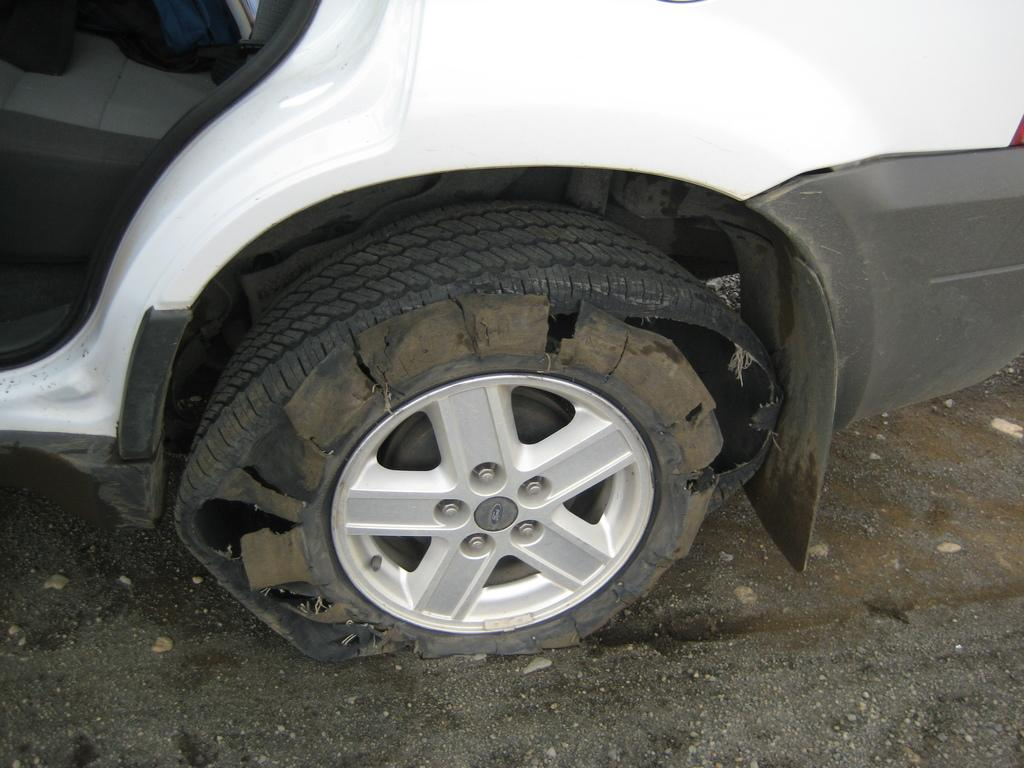What is the main subject of the image? The main subject of the image is a car. What is the condition of one of the car's tires? The car has a punctured tire. Where is the car located in the image? The car is on a path. What is the color of the car? The car is white in color. How does the car increase its speed in the image? The image does not show the car increasing its speed, as it only depicts the car with a punctured tire. What type of thumb design can be seen on the car's steering wheel in the image? There is no thumb design visible on the car's steering wheel in the image, as the steering wheel is not shown. 